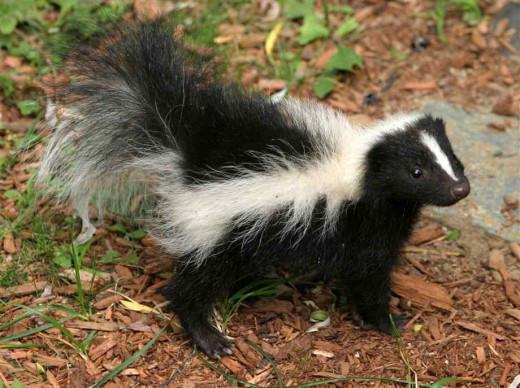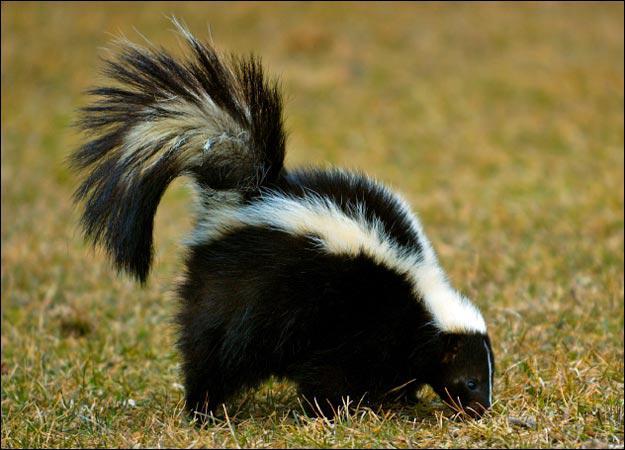The first image is the image on the left, the second image is the image on the right. Considering the images on both sides, is "There are two skunks facing right." valid? Answer yes or no. Yes. 